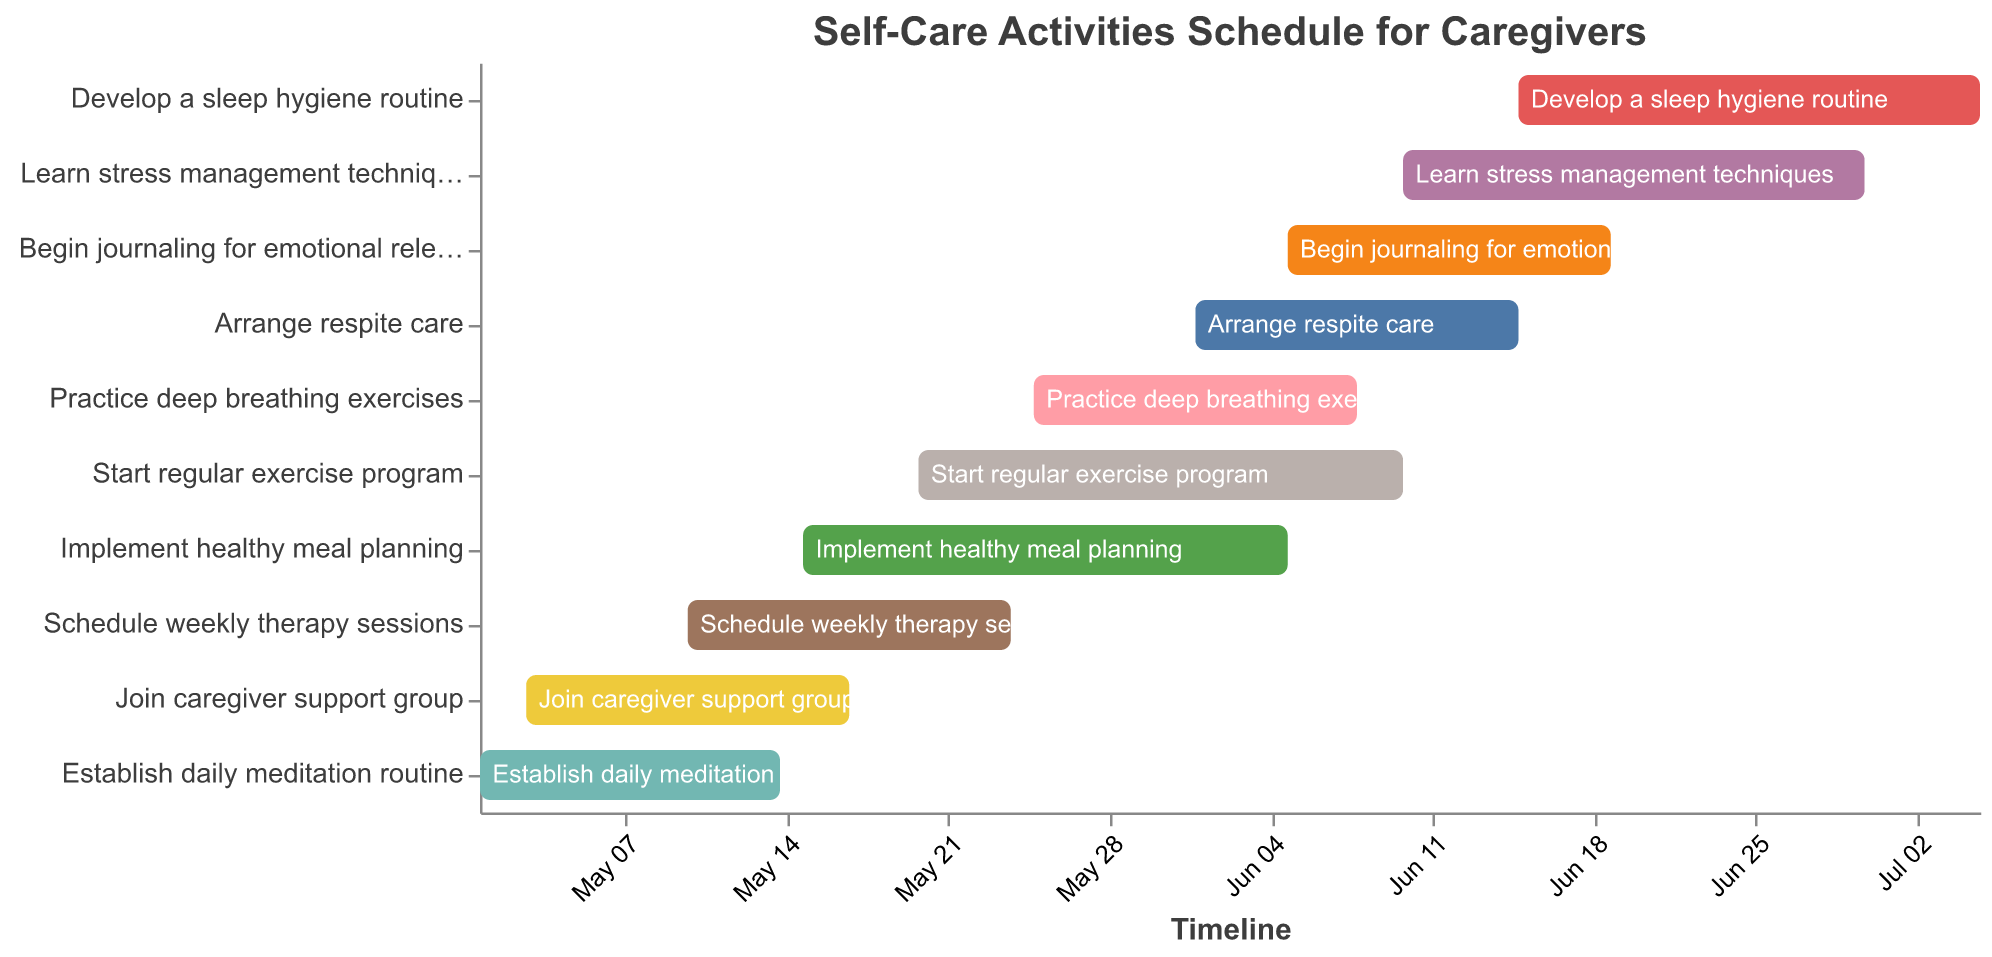What is the title of the figure? The title is usually displayed at the top of the chart. In this case, it states the purpose or contents of the chart.
Answer: Self-Care Activities Schedule for Caregivers Which task starts first? By examining the x-axis for the earliest start date, "Establish daily meditation routine" begins first, on May 1, 2023.
Answer: Establish daily meditation routine What task ends last? To find the task that ends last, look for the rightmost point on the x-axis. "Develop a sleep hygiene routine" ends on July 5, 2023.
Answer: Develop a sleep hygiene routine How long does "Start regular exercise program" last? By comparing its start and end dates (May 20 to June 10), calculate the duration.
Answer: 21 days How many tasks are scheduled to start in June? Count the tasks that have a start date within June in the y-axis. These are: "Arrange respite care," "Begin journaling for emotional release," "Learn stress management techniques," and "Develop a sleep hygiene routine."
Answer: 4 Which task has the shortest duration? By comparing the start and end dates of all tasks, "Establish daily meditation routine" and "Join caregiver support group" both last for 14 days, which is the shortest.
Answer: Establish daily meditation routine or Join caregiver support group Which task overlaps with "Implement healthy meal planning"? Check the timeline against "Implement healthy meal planning" (May 15 - June 5). Overlapping tasks are: "Start regular exercise program," "Practice deep breathing exercises," "Arrage respite care," "Begin journaling for emotional release," and "Schedule weekly therapy sessions."
Answer: Start regular exercise program, Practice deep breathing exercises, Arrange respite care, Begin journaling for emotional release, Schedule weekly therapy sessions What is the total duration of the tasks? Find the overall range from the earliest start date to the latest end date. From May 1 to July 5, 2023, the total duration is 66 days.
Answer: 66 days During which dates do the most tasks overlap? By observing the timeline, consider the range where the most tasks overlap. Here, the range May 25 to June 8 sees multiple overlapping tasks.
Answer: May 25 to June 8 Which task starts immediately after "Establish daily meditation routine"? By looking at the end date of "Establish daily meditation routine" (May 14) and the next task's start date, the following task is "Join caregiver support group" starting on May 3.
Answer: Join caregiver support group 